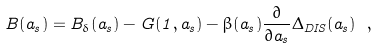<formula> <loc_0><loc_0><loc_500><loc_500>B ( a _ { s } ) = B _ { \delta } ( a _ { s } ) - G ( 1 , a _ { s } ) - \beta ( a _ { s } ) \frac { \partial } { \partial a _ { s } } \Delta _ { D I S } ( a _ { s } ) \ ,</formula> 